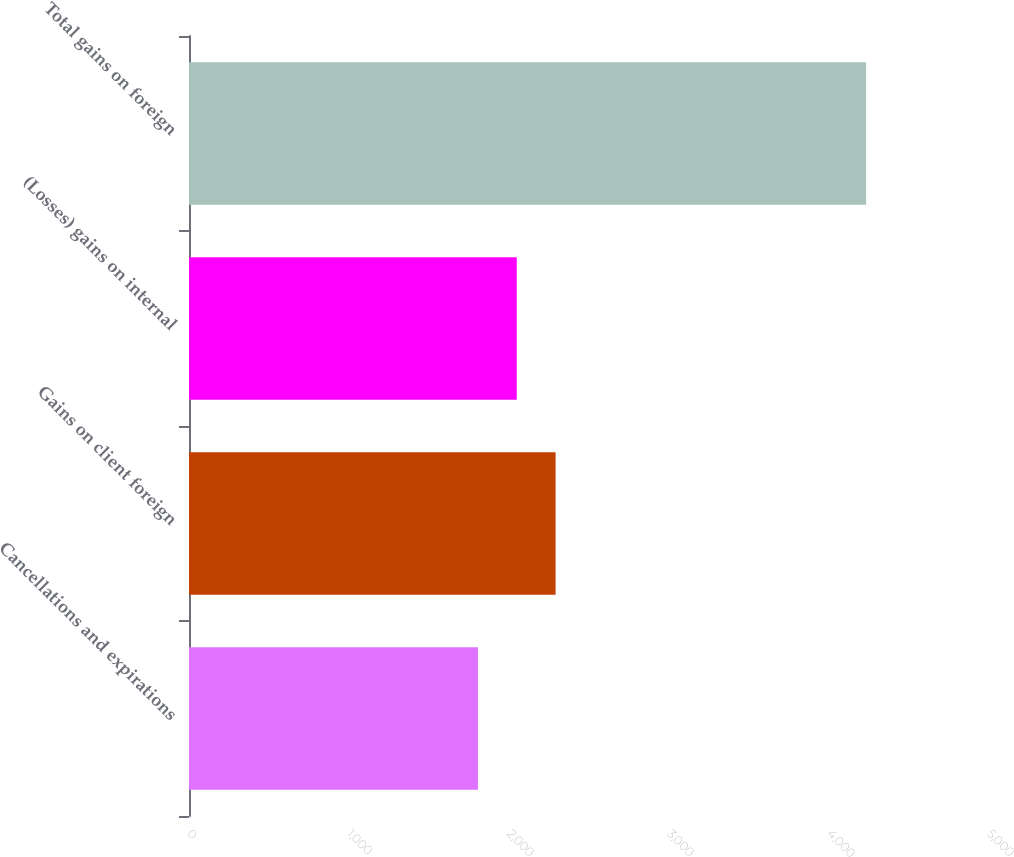Convert chart. <chart><loc_0><loc_0><loc_500><loc_500><bar_chart><fcel>Cancellations and expirations<fcel>Gains on client foreign<fcel>(Losses) gains on internal<fcel>Total gains on foreign<nl><fcel>1806<fcel>2291.2<fcel>2048.6<fcel>4232<nl></chart> 